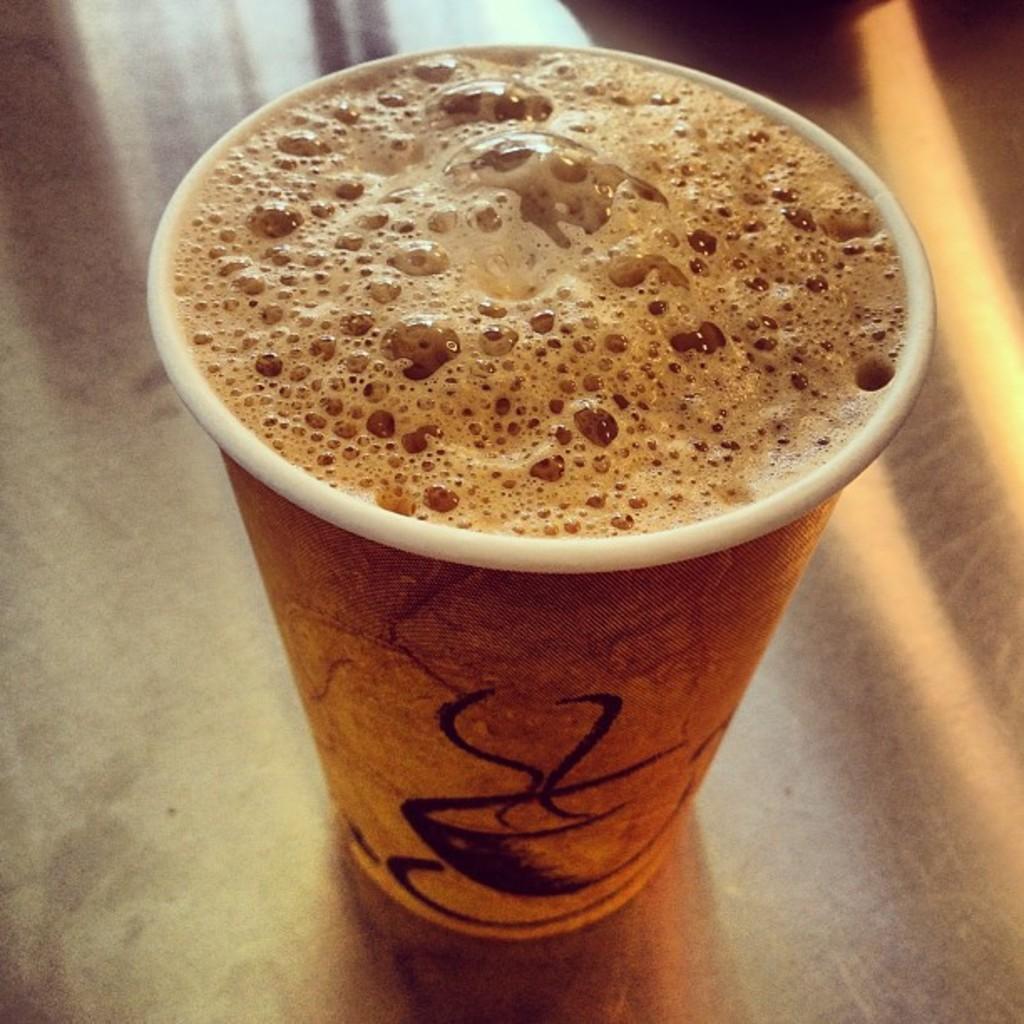Please provide a concise description of this image. In this image I can see a cup, in the cup I can see brown color liquid and the cup is on the table. 